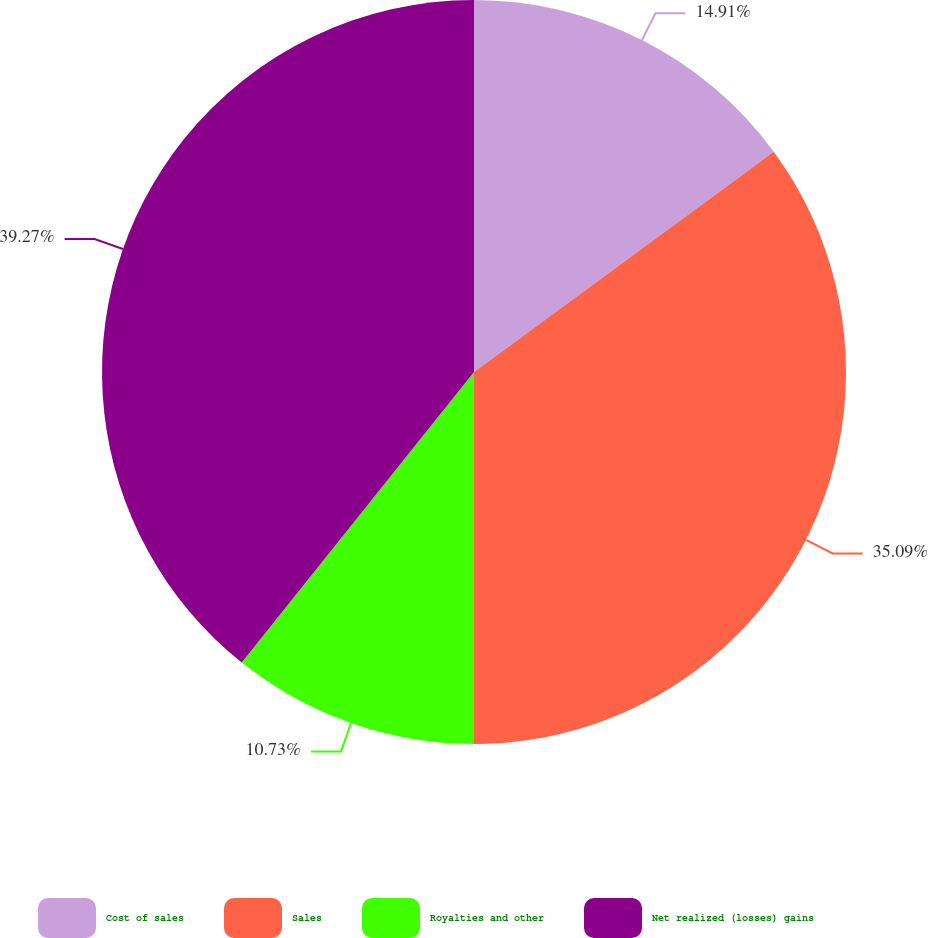Convert chart to OTSL. <chart><loc_0><loc_0><loc_500><loc_500><pie_chart><fcel>Cost of sales<fcel>Sales<fcel>Royalties and other<fcel>Net realized (losses) gains<nl><fcel>14.91%<fcel>35.09%<fcel>10.73%<fcel>39.27%<nl></chart> 